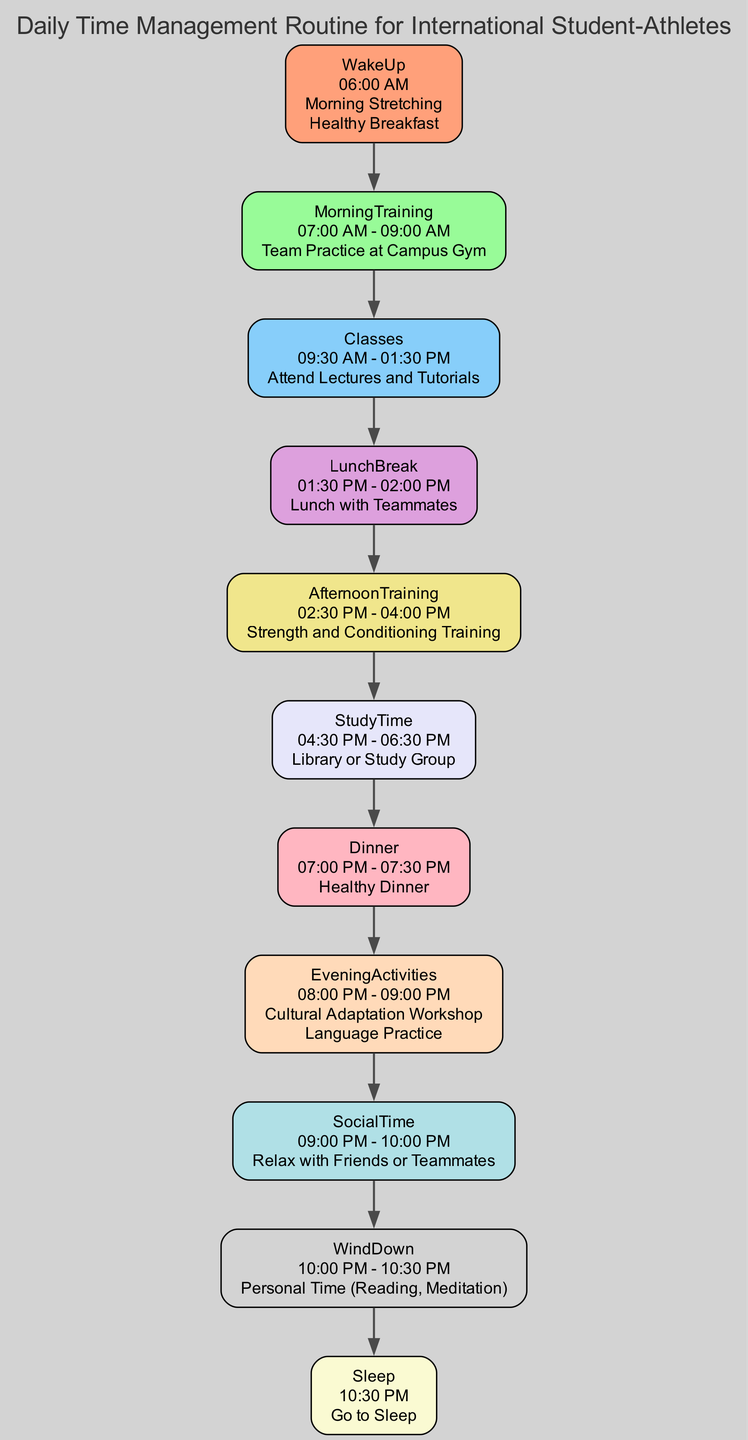What time do you wake up? The "WakeUp" node indicates that the time for waking up is displayed as "06:00 AM."
Answer: 06:00 AM What activity follows lunch? Following the "LunchBreak" node, the next activity listed is "AfternoonTraining."
Answer: Afternoon Training How long is the morning training session? The "MorningTraining" node shows that it lasts from "07:00 AM to 09:00 AM," which is a duration of 2 hours.
Answer: 2 hours What is the common factor between "Dinner" and "EveningActivities"? Both "Dinner" and "EveningActivities" occur after "StudyTime" in the daily routine, indicating they are part of the evening schedule after academic responsibilities.
Answer: Evening activities Which activity takes place at 10:00 PM? The "WindDown" node specifies that this time is allocated for "Personal Time," which includes activities such as reading or meditation.
Answer: Personal Time How many total nodes are in the diagram? Each component of the daily routine from "WakeUp" to "Sleep" counts as a node, totaling 11 distinct nodes in the diagram.
Answer: 11 What is the relationship between "Classes" and "LunchBreak"? The "Classes" node has a direct connection to the "LunchBreak" node as it introduces a break after attending classes, indicating a sequential flow of activities.
Answer: Sequential flow Which activity comes right before sleep? The "WindDown" node is positioned directly before the "Sleep" node, indicating that it is the last activity before going to bed.
Answer: Wind Down What is the duration of the study time? The "StudyTime" node specifies that this period lasts for 2 hours, from "04:30 PM to 06:30 PM."
Answer: 2 hours 